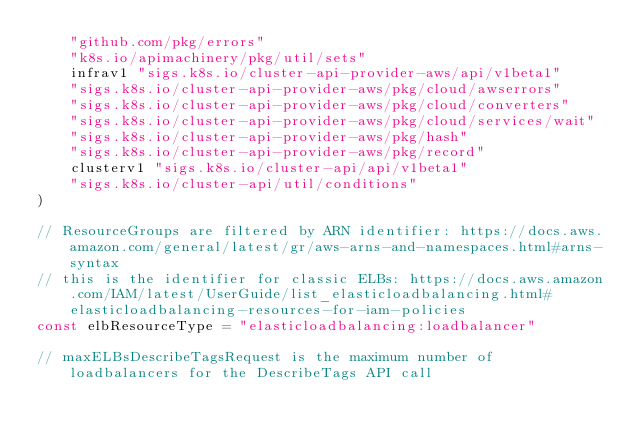<code> <loc_0><loc_0><loc_500><loc_500><_Go_>	"github.com/pkg/errors"
	"k8s.io/apimachinery/pkg/util/sets"
	infrav1 "sigs.k8s.io/cluster-api-provider-aws/api/v1beta1"
	"sigs.k8s.io/cluster-api-provider-aws/pkg/cloud/awserrors"
	"sigs.k8s.io/cluster-api-provider-aws/pkg/cloud/converters"
	"sigs.k8s.io/cluster-api-provider-aws/pkg/cloud/services/wait"
	"sigs.k8s.io/cluster-api-provider-aws/pkg/hash"
	"sigs.k8s.io/cluster-api-provider-aws/pkg/record"
	clusterv1 "sigs.k8s.io/cluster-api/api/v1beta1"
	"sigs.k8s.io/cluster-api/util/conditions"
)

// ResourceGroups are filtered by ARN identifier: https://docs.aws.amazon.com/general/latest/gr/aws-arns-and-namespaces.html#arns-syntax
// this is the identifier for classic ELBs: https://docs.aws.amazon.com/IAM/latest/UserGuide/list_elasticloadbalancing.html#elasticloadbalancing-resources-for-iam-policies
const elbResourceType = "elasticloadbalancing:loadbalancer"

// maxELBsDescribeTagsRequest is the maximum number of loadbalancers for the DescribeTags API call</code> 